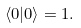Convert formula to latex. <formula><loc_0><loc_0><loc_500><loc_500>\langle 0 | 0 \rangle = 1 .</formula> 